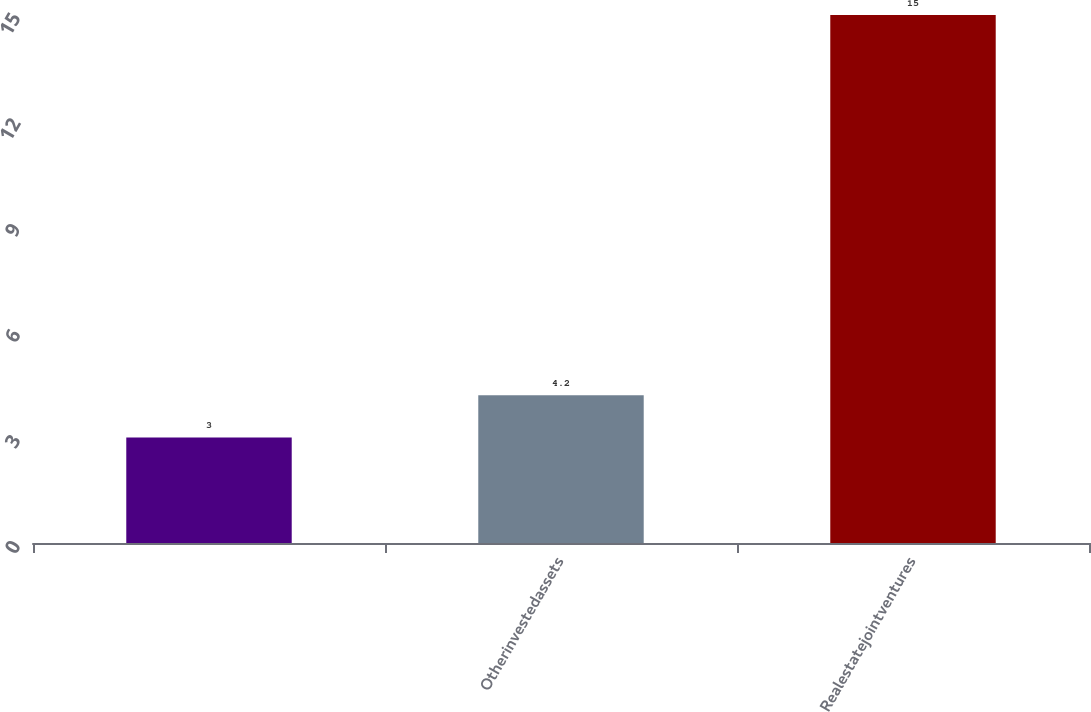Convert chart. <chart><loc_0><loc_0><loc_500><loc_500><bar_chart><ecel><fcel>Otherinvestedassets<fcel>Realestatejointventures<nl><fcel>3<fcel>4.2<fcel>15<nl></chart> 